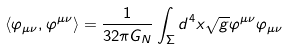<formula> <loc_0><loc_0><loc_500><loc_500>\langle \varphi _ { \mu \nu } , \varphi ^ { \mu \nu } \rangle = \frac { 1 } { 3 2 \pi G _ { N } } \int _ { \Sigma } d ^ { 4 } x \sqrt { g } \varphi ^ { \mu \nu } \varphi _ { \mu \nu }</formula> 